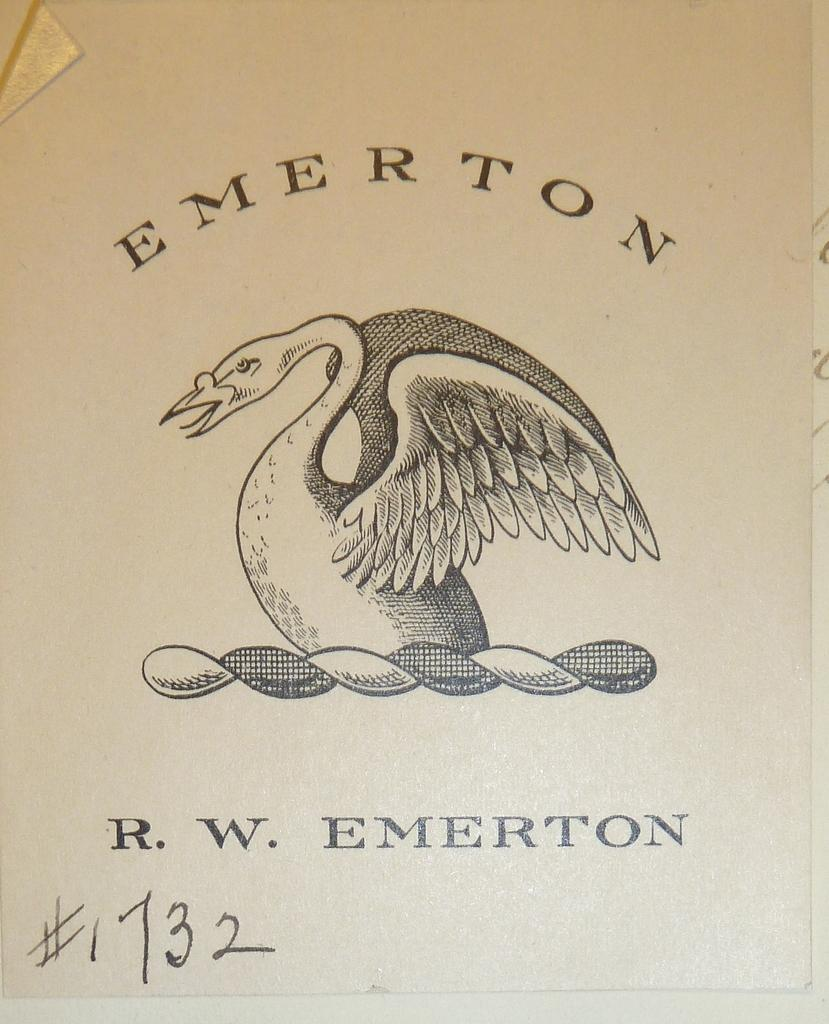What is the primary object in the image? The image contains a paper. What can be found on the paper? There is printed text on the paper. Are there any images or illustrations on the paper? Yes, there is a bird depicted on the paper. What type of discovery is the bird making in the image? There is no indication in the image that the bird is making any discovery, as it is a static illustration on the paper. 